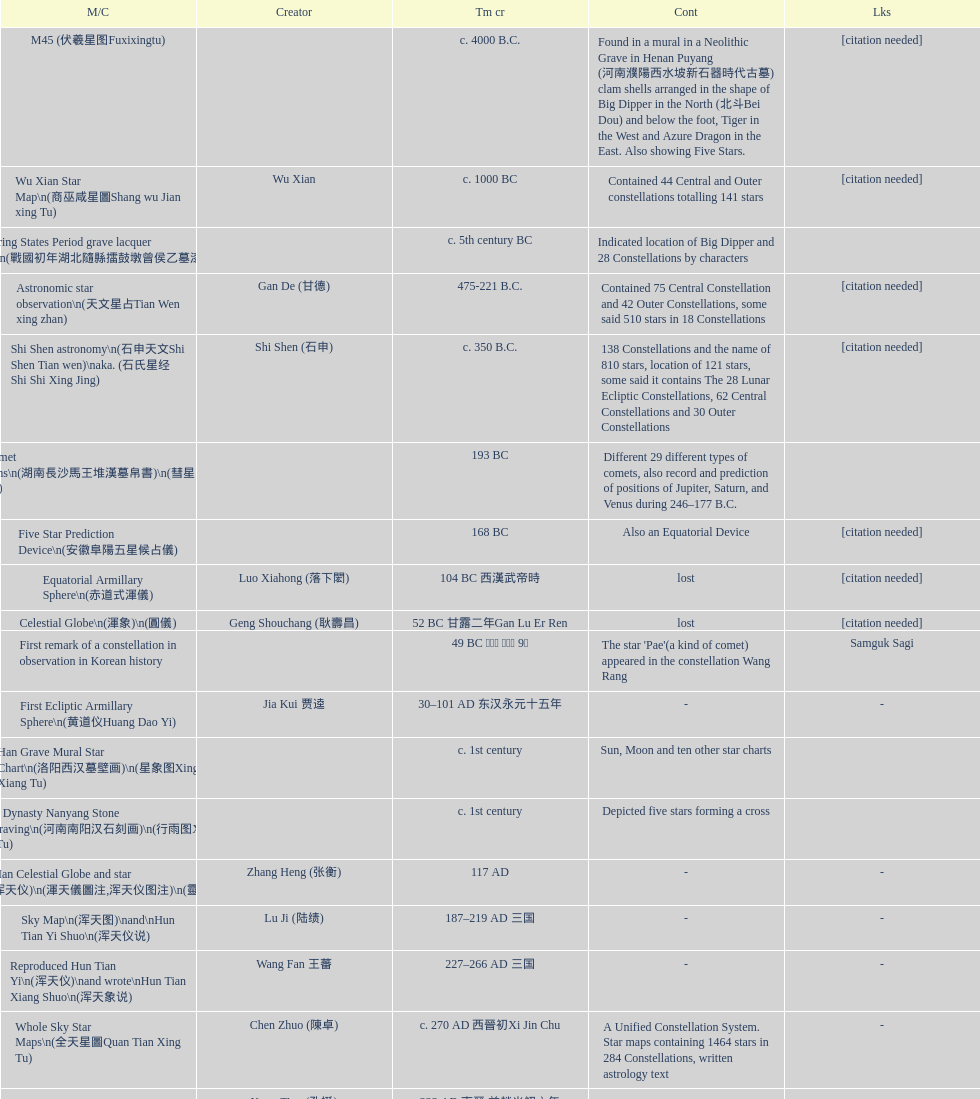Name three items created not long after the equatorial armillary sphere. Celestial Globe (渾象) (圓儀), First remark of a constellation in observation in Korean history, First Ecliptic Armillary Sphere (黄道仪Huang Dao Yi). 